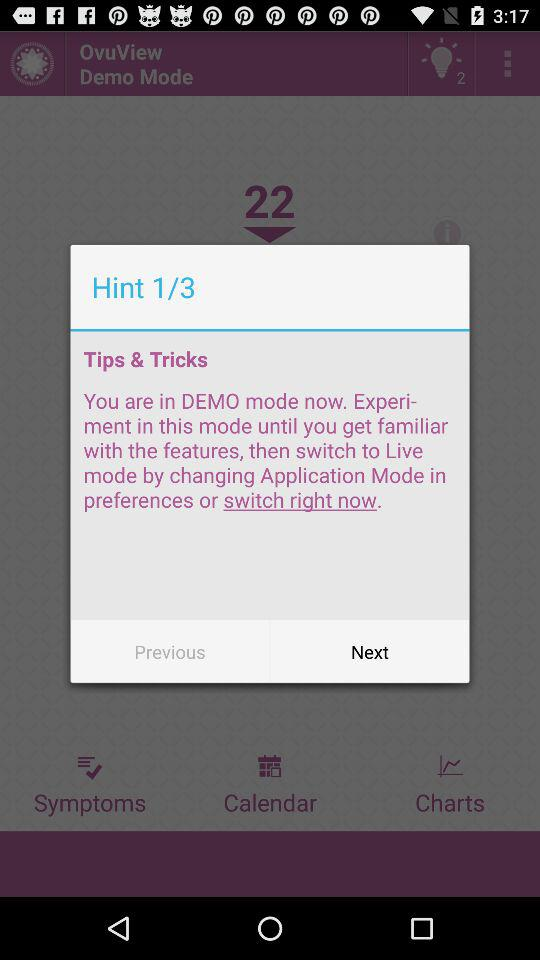Which hint number are we currently on? You are currently on the first hint number. 